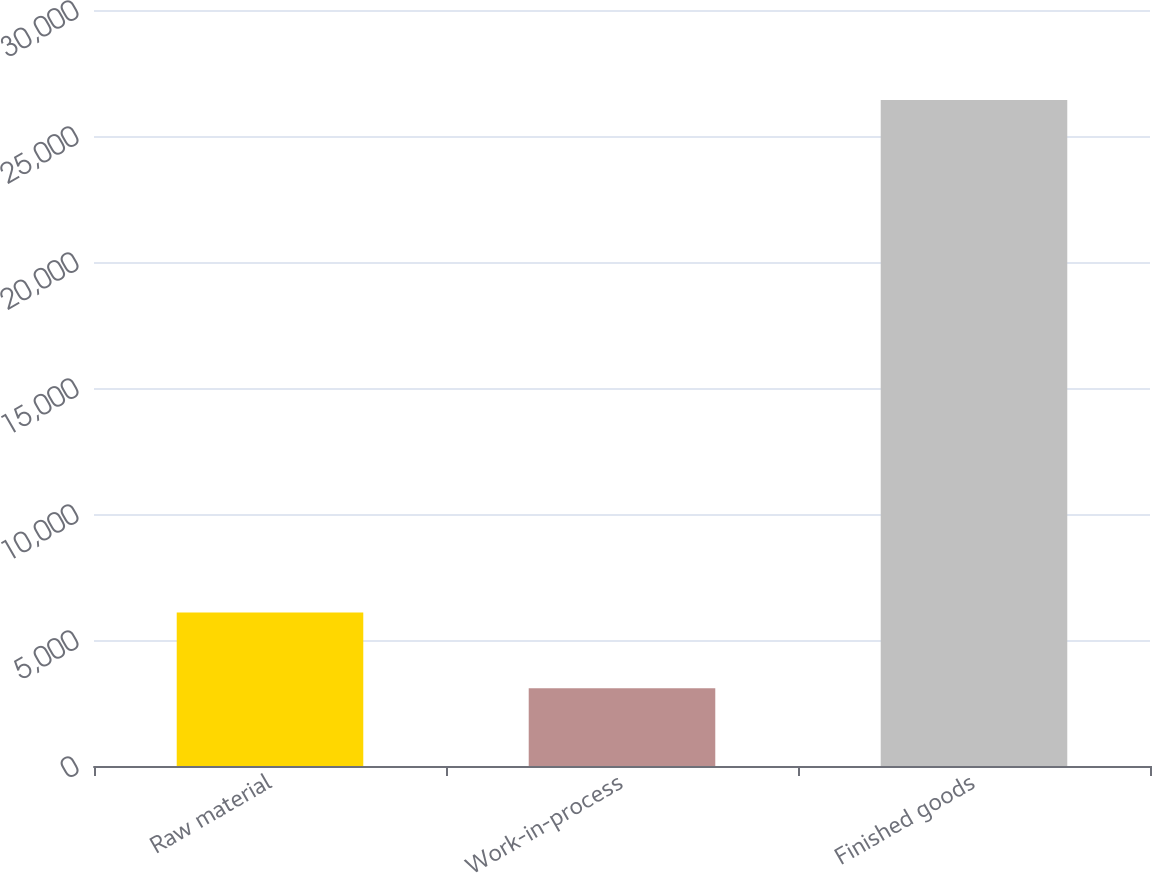Convert chart. <chart><loc_0><loc_0><loc_500><loc_500><bar_chart><fcel>Raw material<fcel>Work-in-process<fcel>Finished goods<nl><fcel>6093<fcel>3089<fcel>26426<nl></chart> 